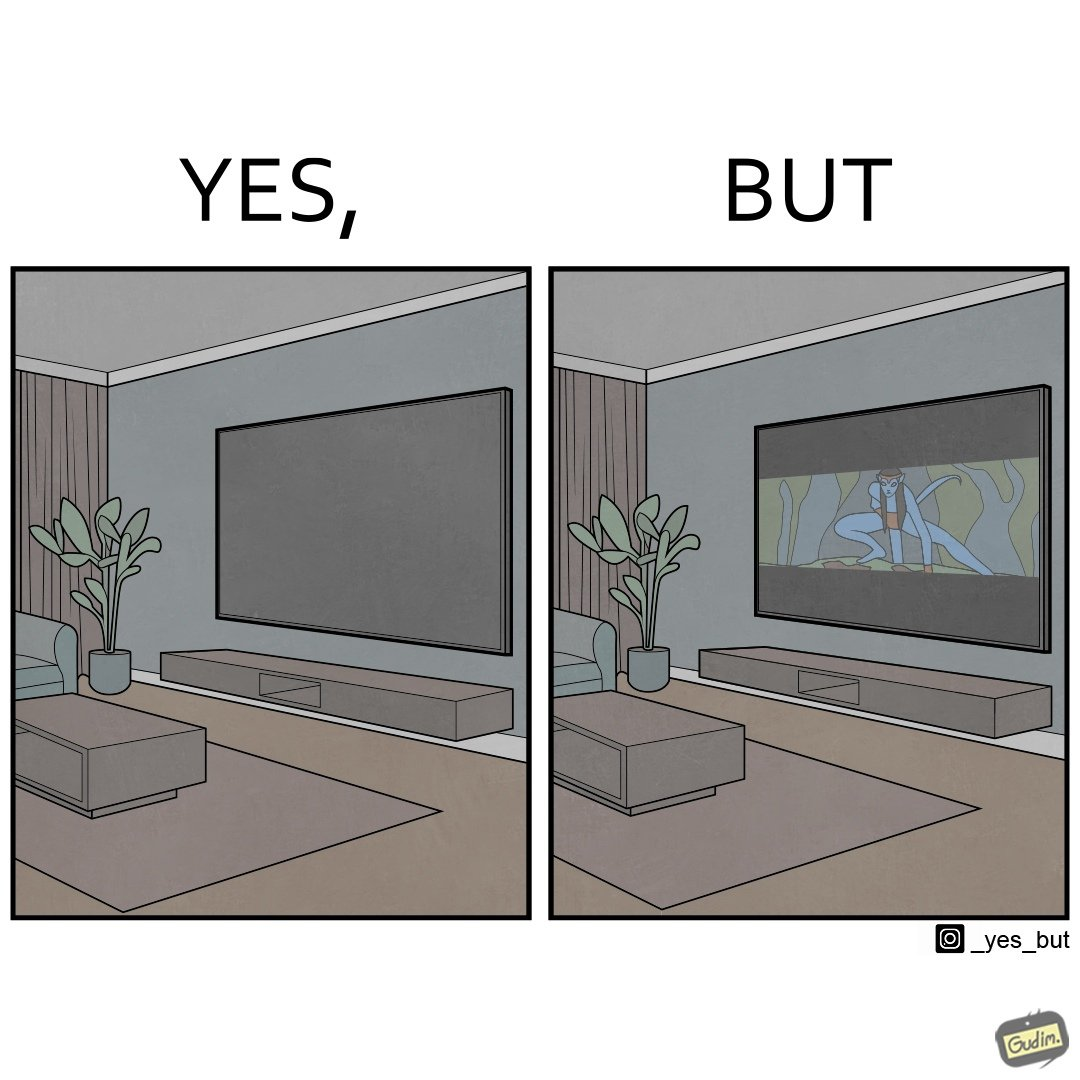Is this a satirical image? Yes, this image is satirical. 